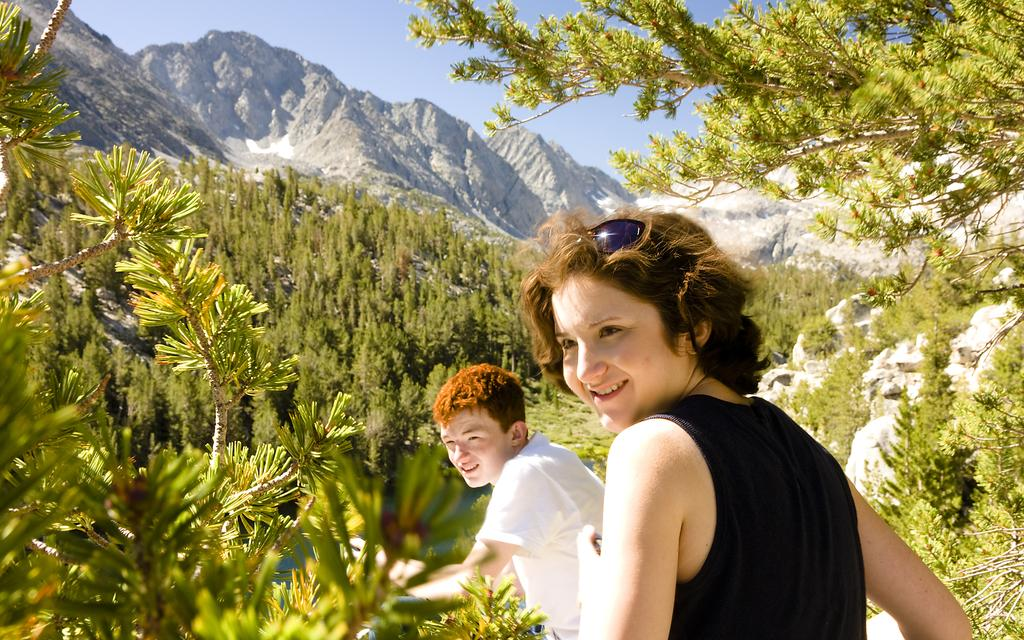How many people are present in the image? There are two people in the image. What are the people wearing? Both people are wearing black and white color dresses. What can be seen in the background of the image? There are green trees and mountains visible in the background. What is the color of the sky in the image? The sky is blue in color. What type of plot is the girl standing on in the image? There is no girl present in the image, so there is no plot for her to stand on. 